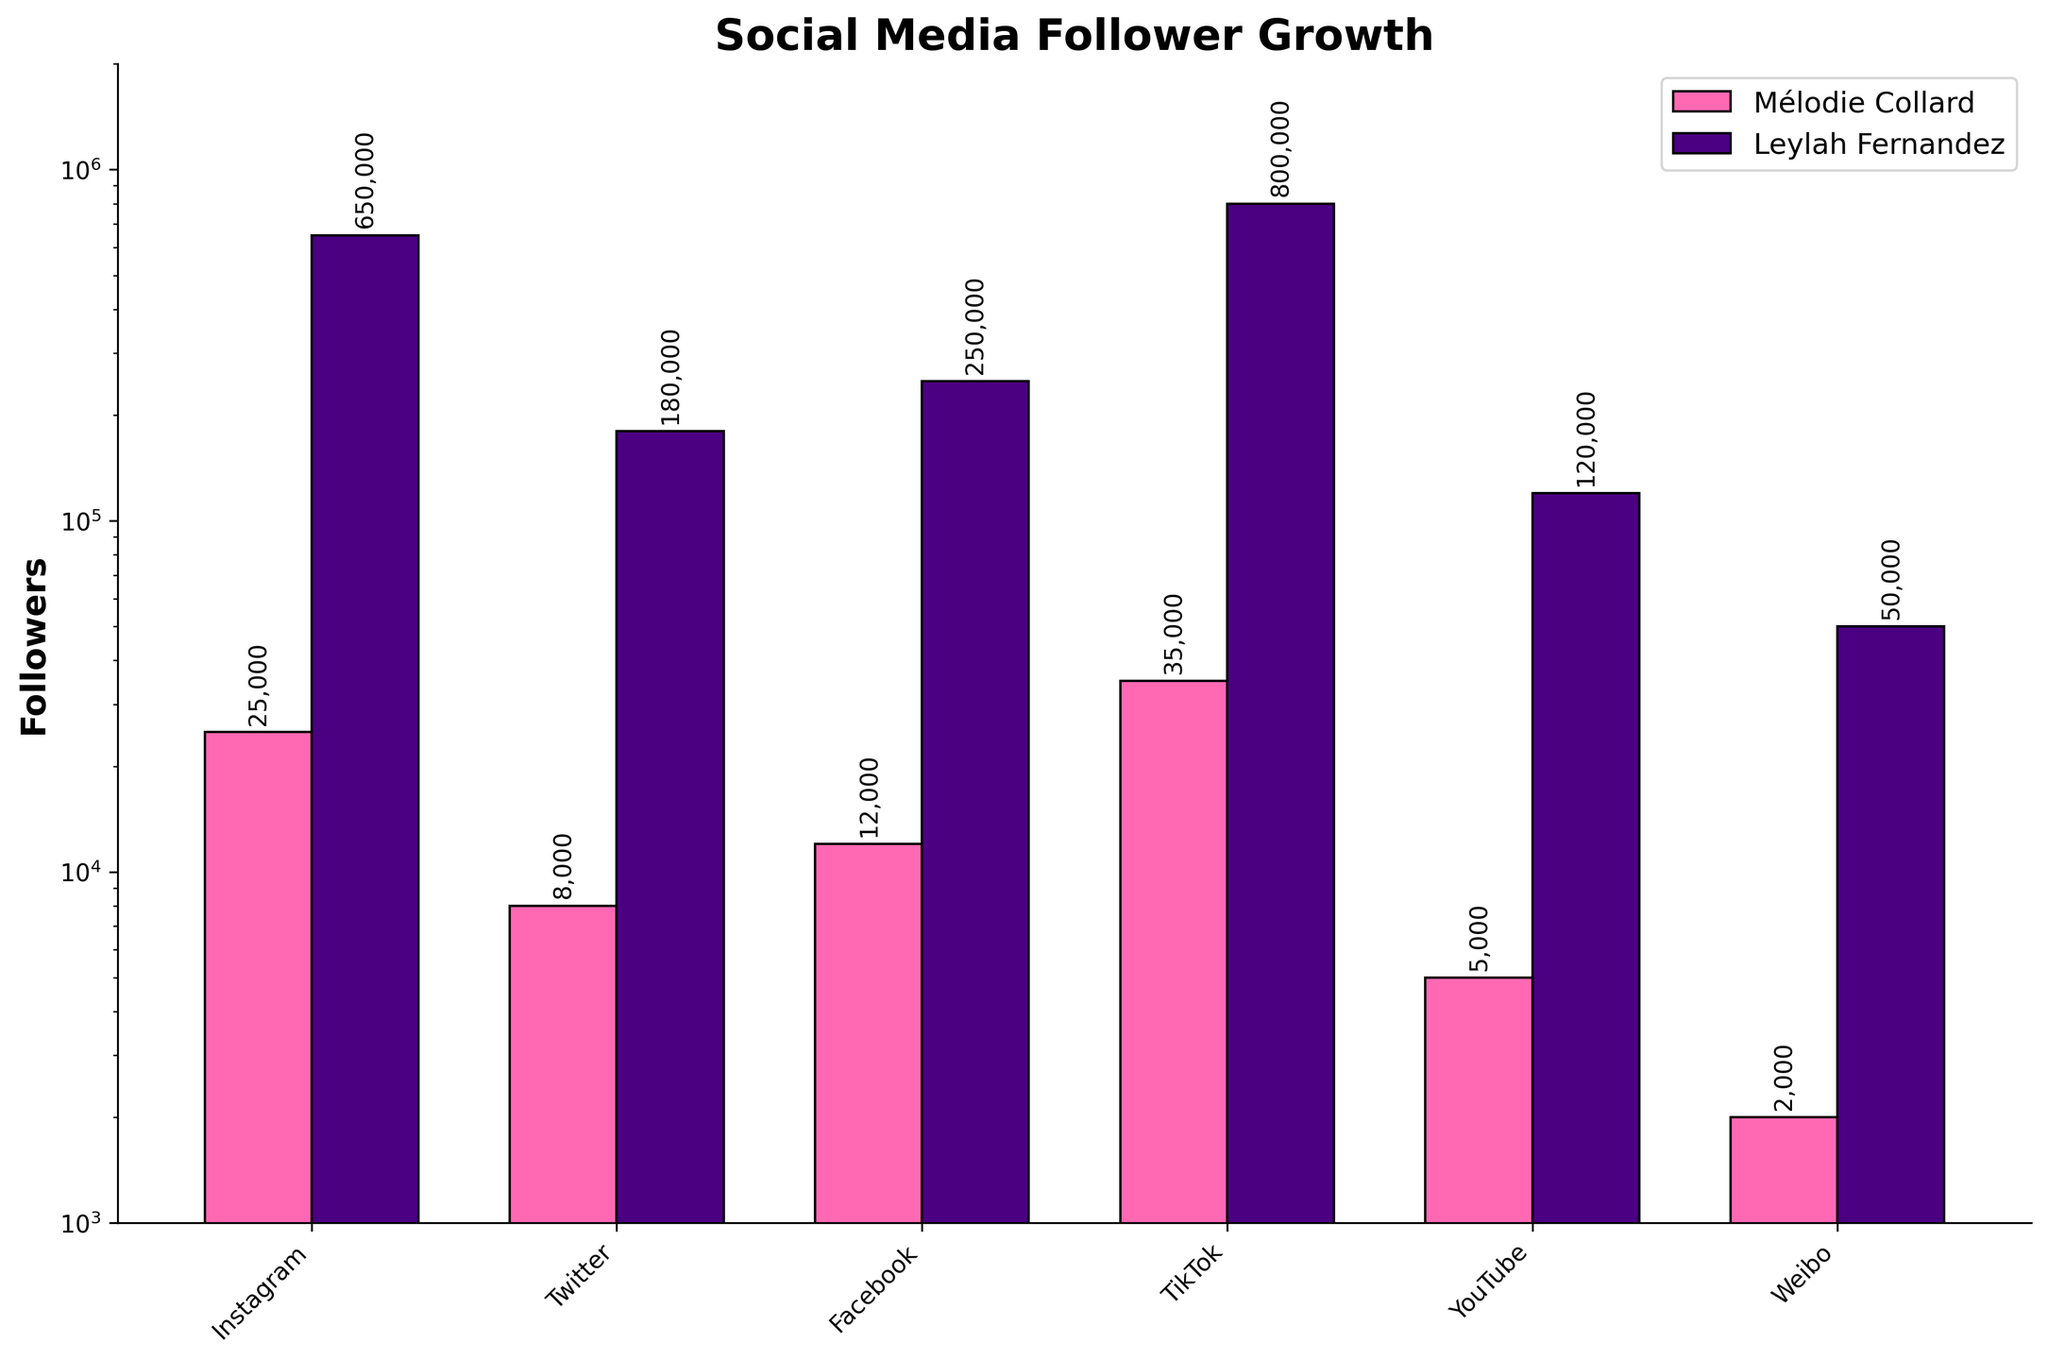Which platform does Leylah Fernandez have the most followers on? The tallest purple bar in the chart represents Leylah Fernandez's TikTok followers. By comparing the height of the purple bars, it's clear that Leylah has the most followers on TikTok.
Answer: TikTok What is the difference in Instagram followers between Mélodie Collard and Leylah Fernandez? Mélodie Collard has 25,000 Instagram followers, and Leylah Fernandez has 650,000. Subtracting the two amounts: 650,000 - 25,000 = 625,000.
Answer: 625,000 Which platform does Mélodie Collard have the least followers on, and how many? The shortest pink bar in the chart represents Mélodie Collard's Weibo followers. The figure adjacent to this bar shows 2,000.
Answer: Weibo, 2,000 How many total followers does Mélodie Collard have across all platforms? Summing up all the followers for Mélodie Collard: 25,000 (Instagram) + 8,000 (Twitter) + 12,000 (Facebook) + 35,000 (TikTok) + 5,000 (YouTube) + 2,000 (Weibo) = 87,000.
Answer: 87,000 What's the average number of Twitter followers for both Mélodie Collard and Leylah Fernandez? Mélodie Collard has 8,000 Twitter followers and Leylah Fernandez has 180,000. The average is calculated as (8,000 + 180,000) / 2 = 94,000.
Answer: 94,000 Do both Mélodie Collard and Leylah Fernandez have more followers on TikTok than on Instagram? Mélodie Collard has 25,000 followers on Instagram and 35,000 on TikTok. Leylah Fernandez has 650,000 followers on Instagram and 800,000 on TikTok. Both athletes have more followers on TikTok than on Instagram.
Answer: Yes What is the sum of Leylah Fernandez's followers on Facebook and YouTube? Leylah Fernandez has 250,000 Facebook followers and 120,000 YouTube followers. The sum is 250,000 + 120,000 = 370,000.
Answer: 370,000 